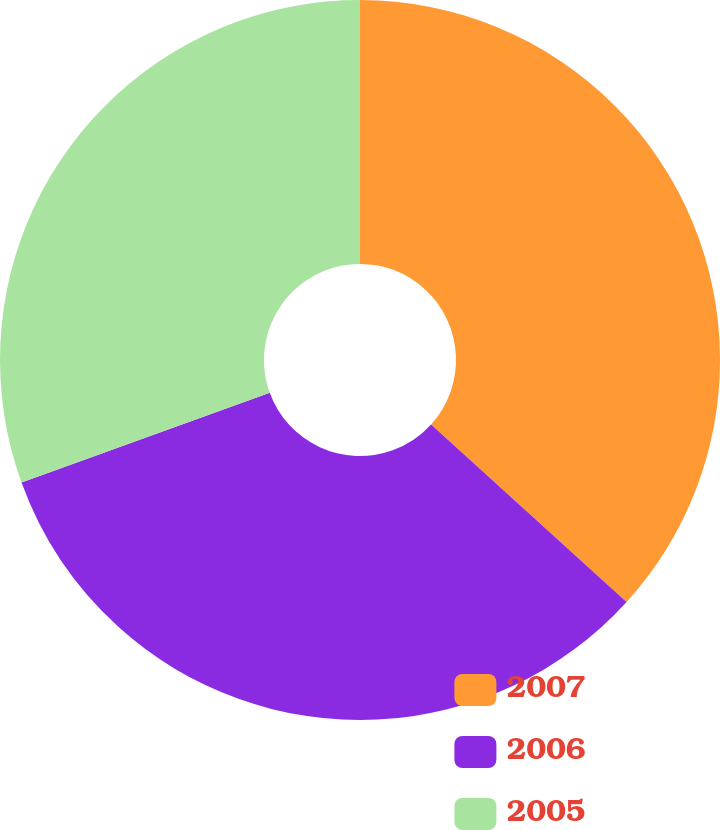Convert chart. <chart><loc_0><loc_0><loc_500><loc_500><pie_chart><fcel>2007<fcel>2006<fcel>2005<nl><fcel>36.73%<fcel>32.74%<fcel>30.53%<nl></chart> 